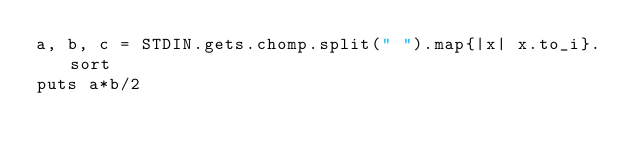Convert code to text. <code><loc_0><loc_0><loc_500><loc_500><_Ruby_>a, b, c = STDIN.gets.chomp.split(" ").map{|x| x.to_i}.sort
puts a*b/2</code> 